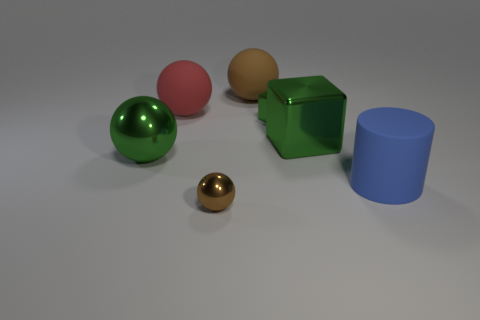What number of things are either big metal things that are on the right side of the tiny brown metal sphere or green things? There are two large metal objects to the right of the small brown metal sphere – a pink sphere and a green cube. Additionally, there is one green sphere present in the image. Therefore, the total number of objects that are either big metal things on the right side of the tiny brown metal sphere or green things is three. 